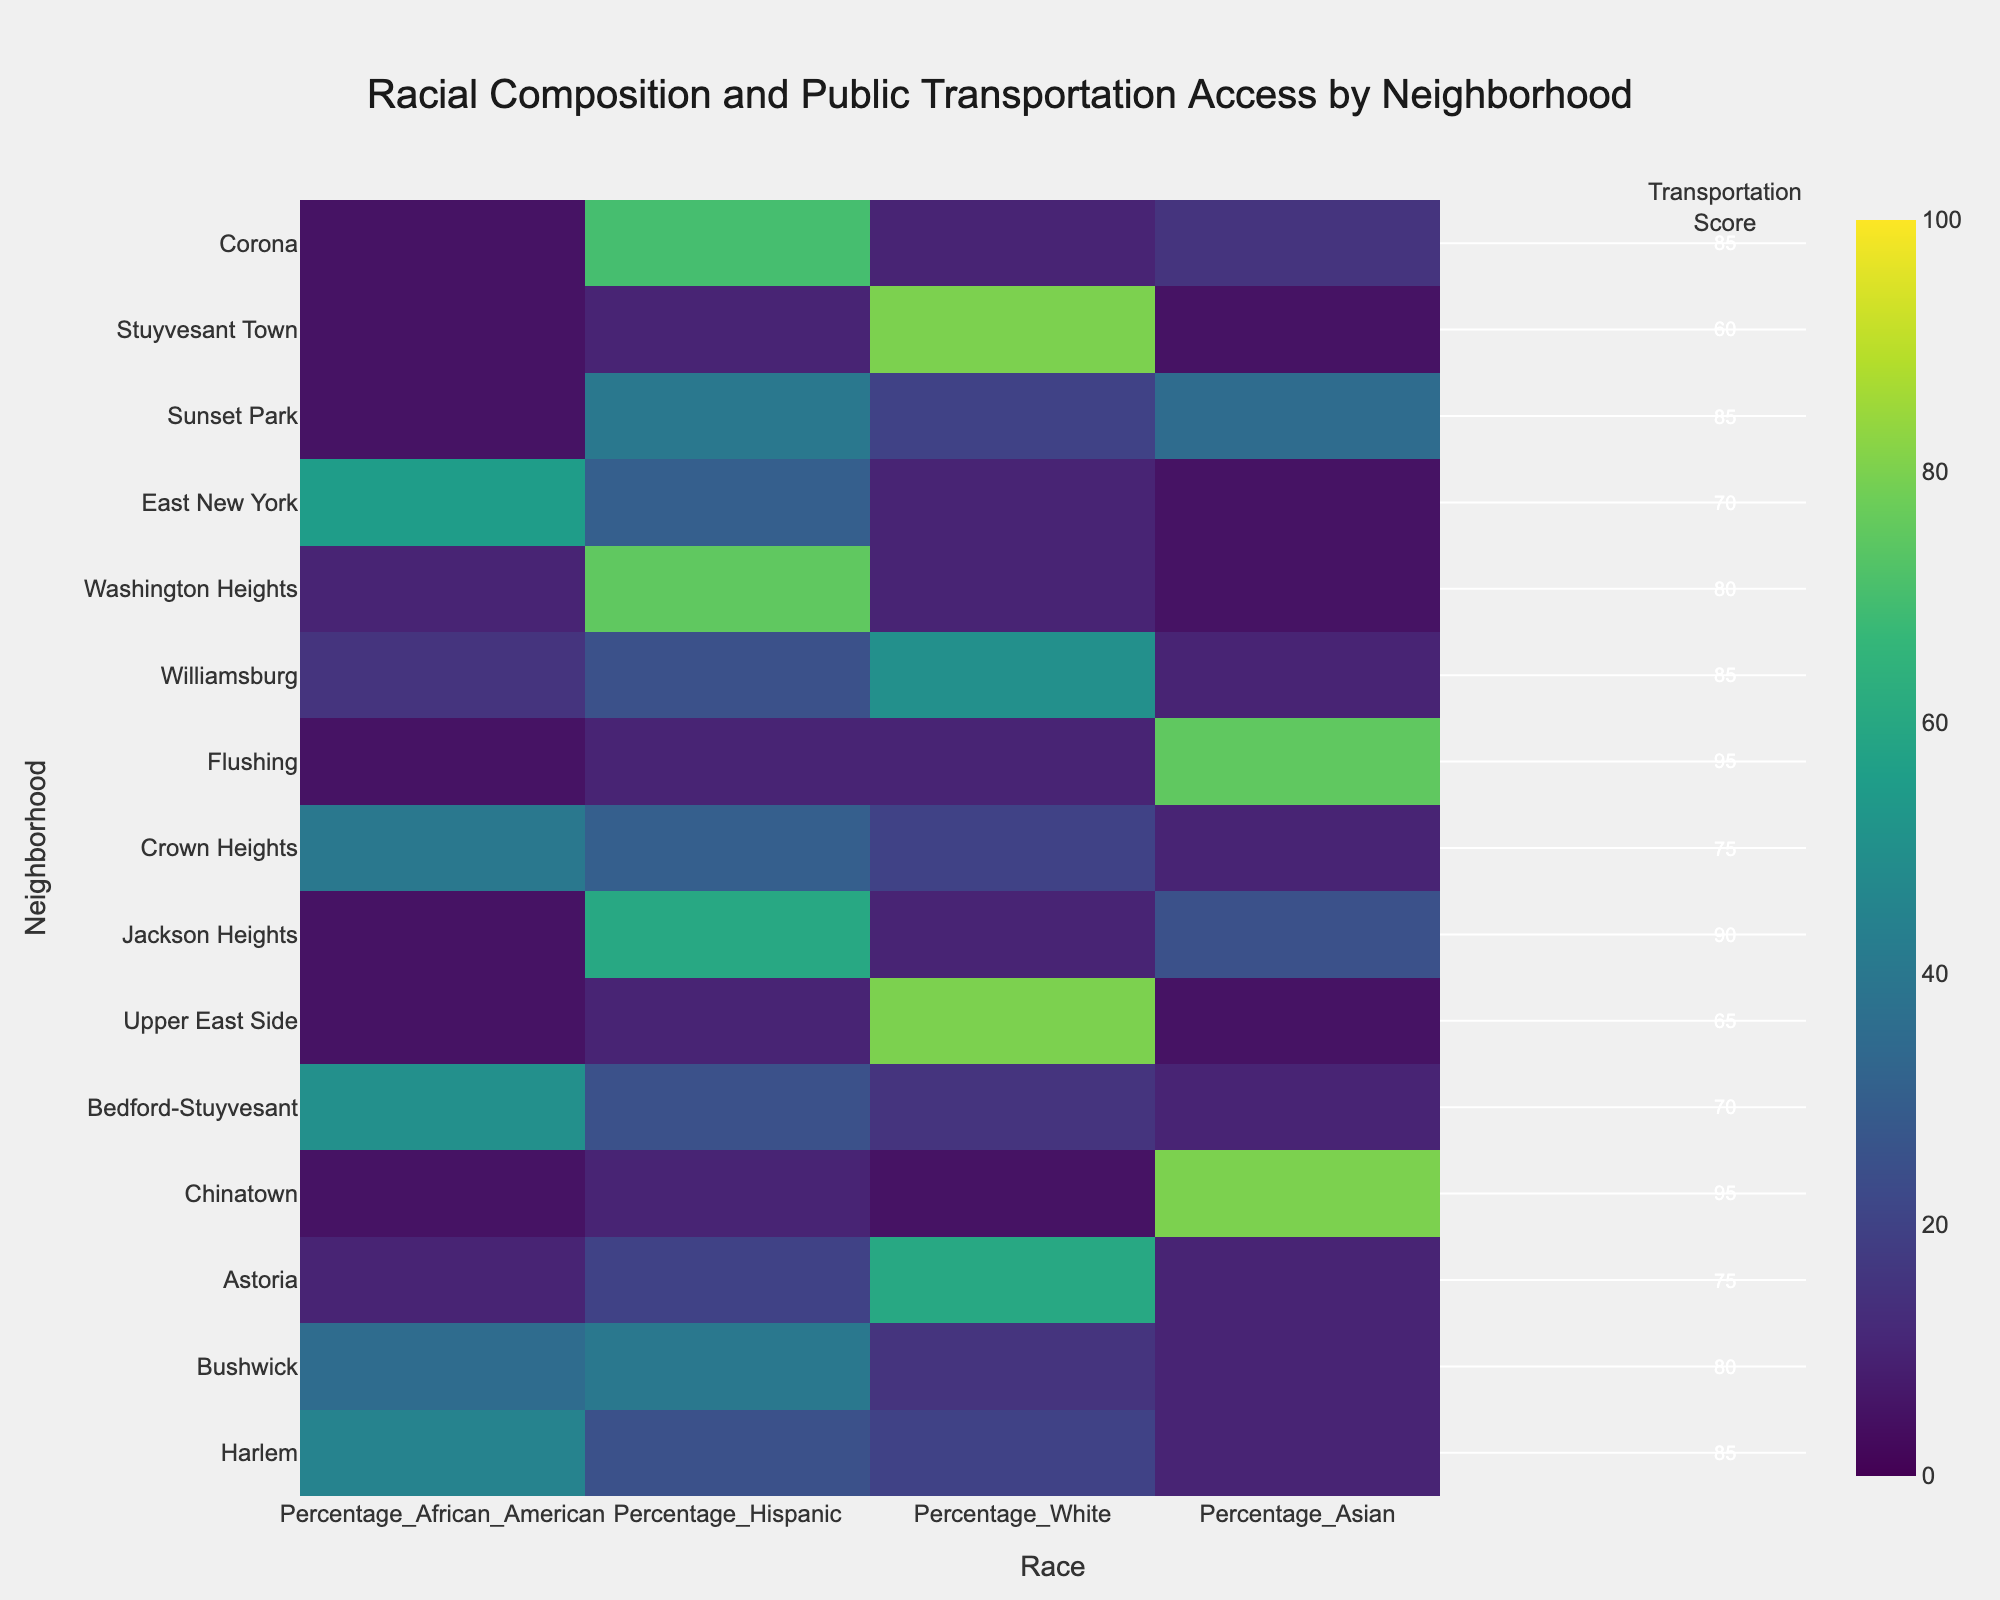What is the neighborhood with the highest access to public transportation score? The neighborhood with the highest access to public transportation score can be identified by looking at the annotations in the heatmap and finding the highest number.
Answer: Chinatown Which neighborhood has the lowest percentage of Hispanic residents? To find the neighborhood with the lowest percentage of Hispanic residents, locate the bar representing Hispanic residents on the x-axis and identify the neighborhood with the smallest percentage.
Answer: Chinatown and Upper East Side How does the percentage of African American residents in Bedford-Stuyvesant compare to Crown Heights? Compare the percentage values for African American residents in Bedford-Stuyvesant and Crown Heights.
Answer: Higher in Bedford-Stuyvesant Which racial group has the highest representation in Flushing? Identify the racial group with the largest percentage value in the row representing Flushing.
Answer: Asian What is the range of public transportation scores present in the heatmap? Find the minimum and maximum values of the public transportation scores annotated in the heatmap.
Answer: 60-95 Which neighborhood has the most balanced racial composition? Look for the neighborhood where the percentages for each racial group are closest to each other without any significant majority.
Answer: Bushwick Is access to public transportation in Upper East Side above or below the median score? Calculate the median of the public transportation scores and compare it with the score for the Upper East Side.
Answer: Below Which neighborhood has a public transportation score of 85 and a significant Hispanic population? Identify neighborhoods with a public transportation score of 85 and check the Hispanic percentage for each to find a significant value.
Answer: Bushwick and Corona What is the mean access to public transportation score for neighborhoods with a significant Asian population (more than 50%)? First, find neighborhoods where the Asian population is more than 50%, then calculate the mean of their public transportation scores.
Answer: (95+95)/2 = 95 Do neighborhoods with higher percentages of White residents tend to have lower or higher public transportation scores? Compare the public transportation scores in neighborhoods with high percentages of White residents.
Answer: Tend to have lower scores 